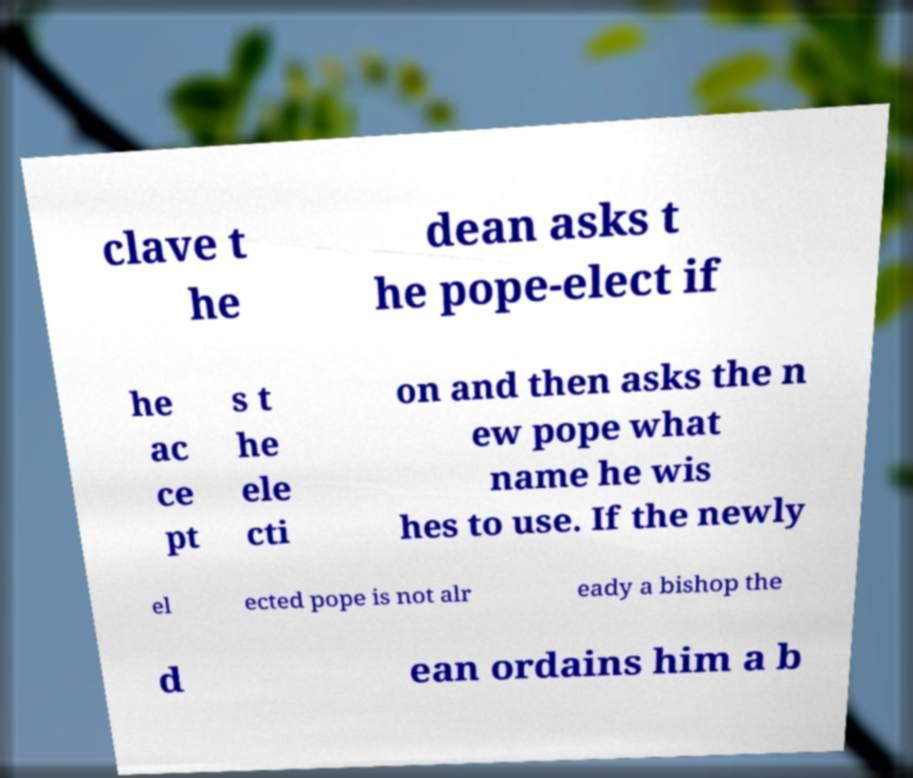Can you read and provide the text displayed in the image?This photo seems to have some interesting text. Can you extract and type it out for me? clave t he dean asks t he pope-elect if he ac ce pt s t he ele cti on and then asks the n ew pope what name he wis hes to use. If the newly el ected pope is not alr eady a bishop the d ean ordains him a b 